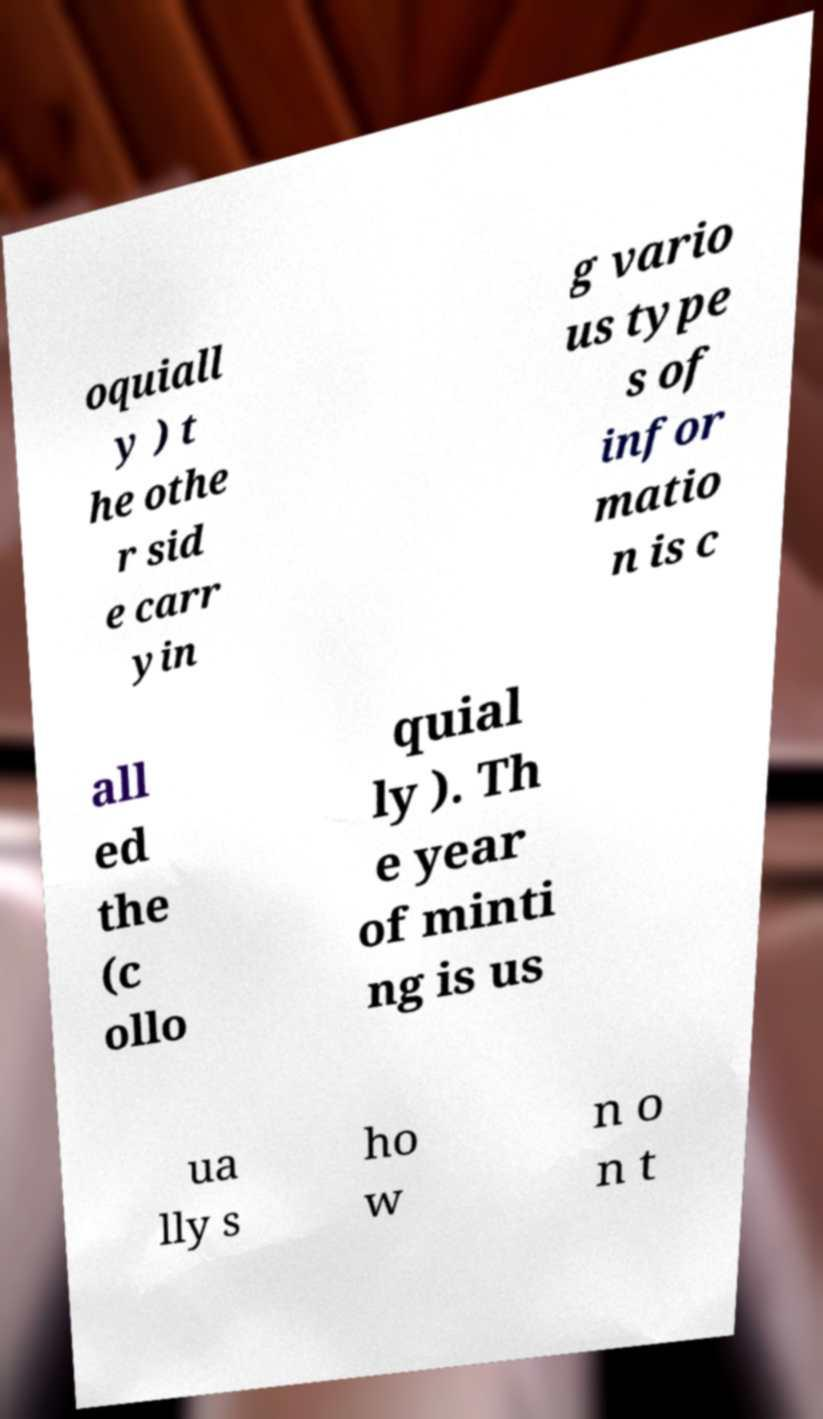There's text embedded in this image that I need extracted. Can you transcribe it verbatim? oquiall y ) t he othe r sid e carr yin g vario us type s of infor matio n is c all ed the (c ollo quial ly ). Th e year of minti ng is us ua lly s ho w n o n t 